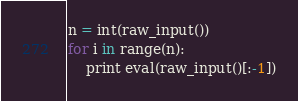<code> <loc_0><loc_0><loc_500><loc_500><_Python_>n = int(raw_input())
for i in range(n):
    print eval(raw_input()[:-1])</code> 